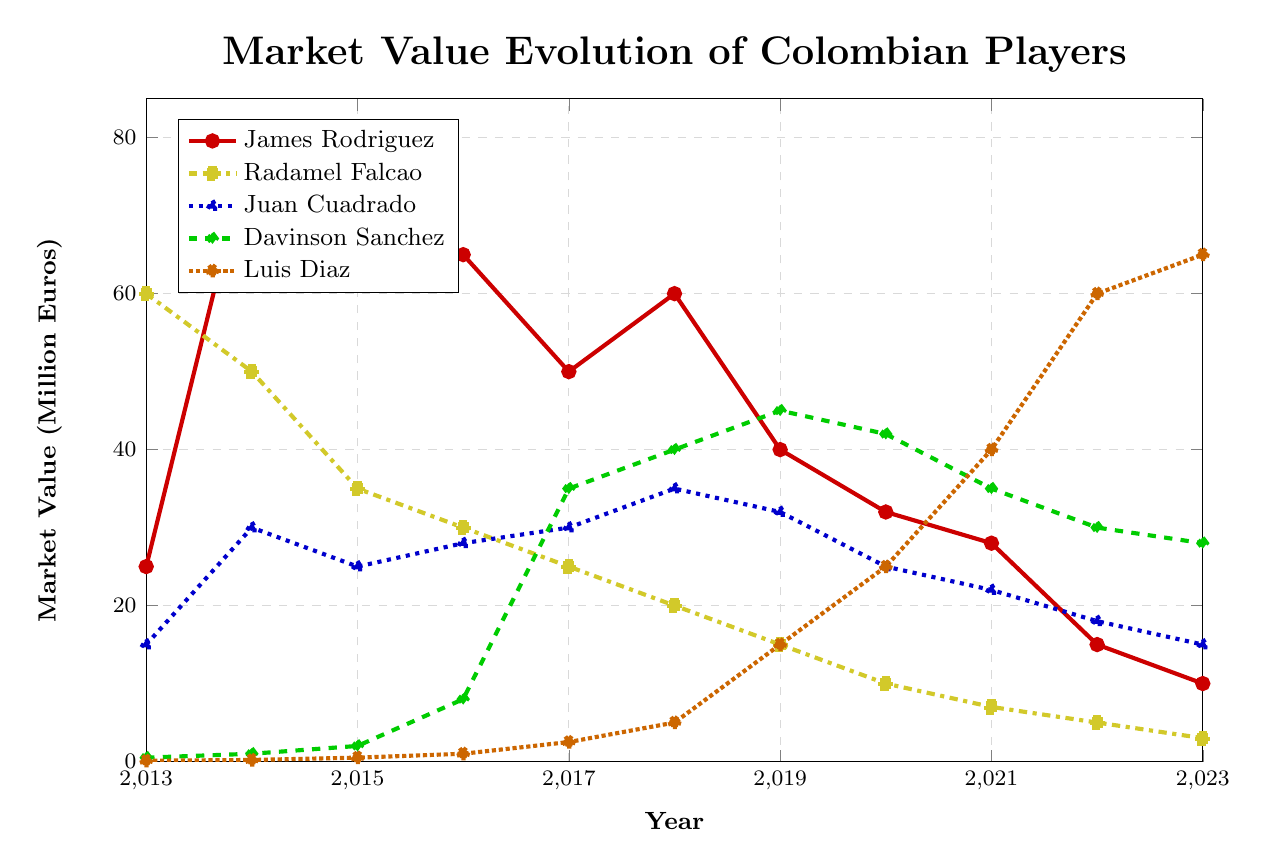What is the peak market value reached by James Rodriguez and in which year? Looking at James Rodriguez's line, his highest market value is seen in the year 2014.
Answer: 80.0 million euros in 2014 Which player had the highest market value in 2020? By comparing the market values in the year 2020, Luis Diaz has the highest market value among all players.
Answer: Luis Diaz Who had a higher market value in 2018, Davinson Sanchez or Juan Cuadrado? Looking at the values for 2018, Davinson Sanchez had a market value of 40.0 million euros, while Juan Cuadrado had 35.0 million euros.
Answer: Davinson Sanchez How did the market value trend of Radamel Falcao change from 2013 to 2023? Radamel Falcao's market value decreased consistently from 60.0 million euros in 2013 to 3.0 million euros in 2023.
Answer: Decreased consistently Which player displayed the most significant increase in market value from 2013 to 2023? Comparing the values from 2013 to 2023 for each player, Luis Diaz increased from 0.1 million euros to 65.0 million euros, which is the largest increase.
Answer: Luis Diaz What is the difference in market value between Juan Cuadrado and James Rodriguez in 2015? For 2015, Juan Cuadrado's market value is 25.0 million euros, and James Rodriguez's value is 70.0 million euros. The difference is 70.0 - 25.0.
Answer: 45.0 million euros How many players had a market value of at least 30 million euros at any point between 2013 and 2023? By examining the values over the years, James Rodriguez, Radamel Falcao, Juan Cuadrado, Davinson Sanchez, and Luis Diaz each reached at least 30 million euros at some point.
Answer: 5 players In which year did Davinson Sanchez witness the highest market value, and what was the value? By looking at Davinson Sanchez's curve, the peak is in 2019 with a market value of 45.0 million euros.
Answer: 2019, 45.0 million euros Who had the lowest market value in 2013, and what was it? The lowest market value in 2013 belongs to Luis Diaz at 0.1 million euros.
Answer: Luis Diaz, 0.1 million euros What was the average market value of James Rodriguez from 2014 to 2018? Summing the values from 2014 to 2018 for James Rodriguez (80.0 + 70.0 + 65.0 + 50.0 + 60.0) and dividing by the number of years (5), we get an average of 65.0 million euros.
Answer: 65.0 million euros 